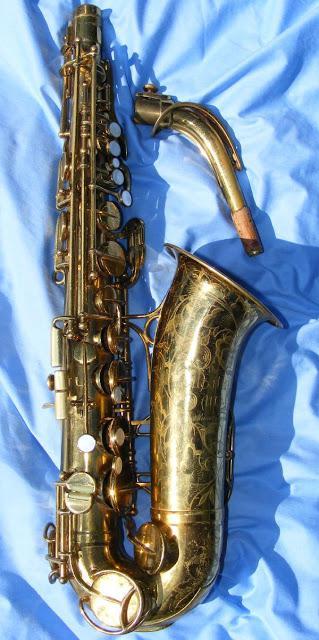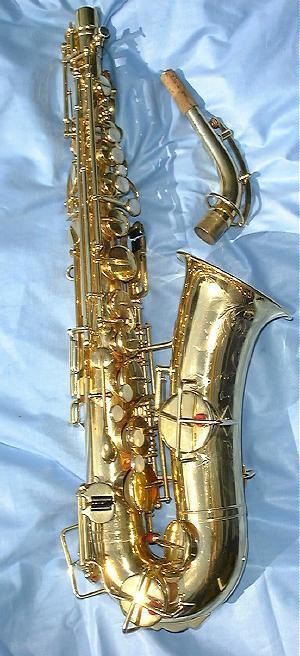The first image is the image on the left, the second image is the image on the right. Analyze the images presented: Is the assertion "There are only two saxophones." valid? Answer yes or no. Yes. 